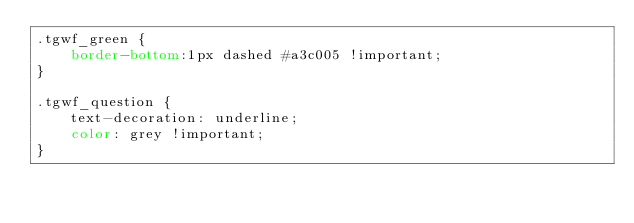Convert code to text. <code><loc_0><loc_0><loc_500><loc_500><_CSS_>.tgwf_green {
    border-bottom:1px dashed #a3c005 !important;
}

.tgwf_question {
    text-decoration: underline;
    color: grey !important;
}</code> 